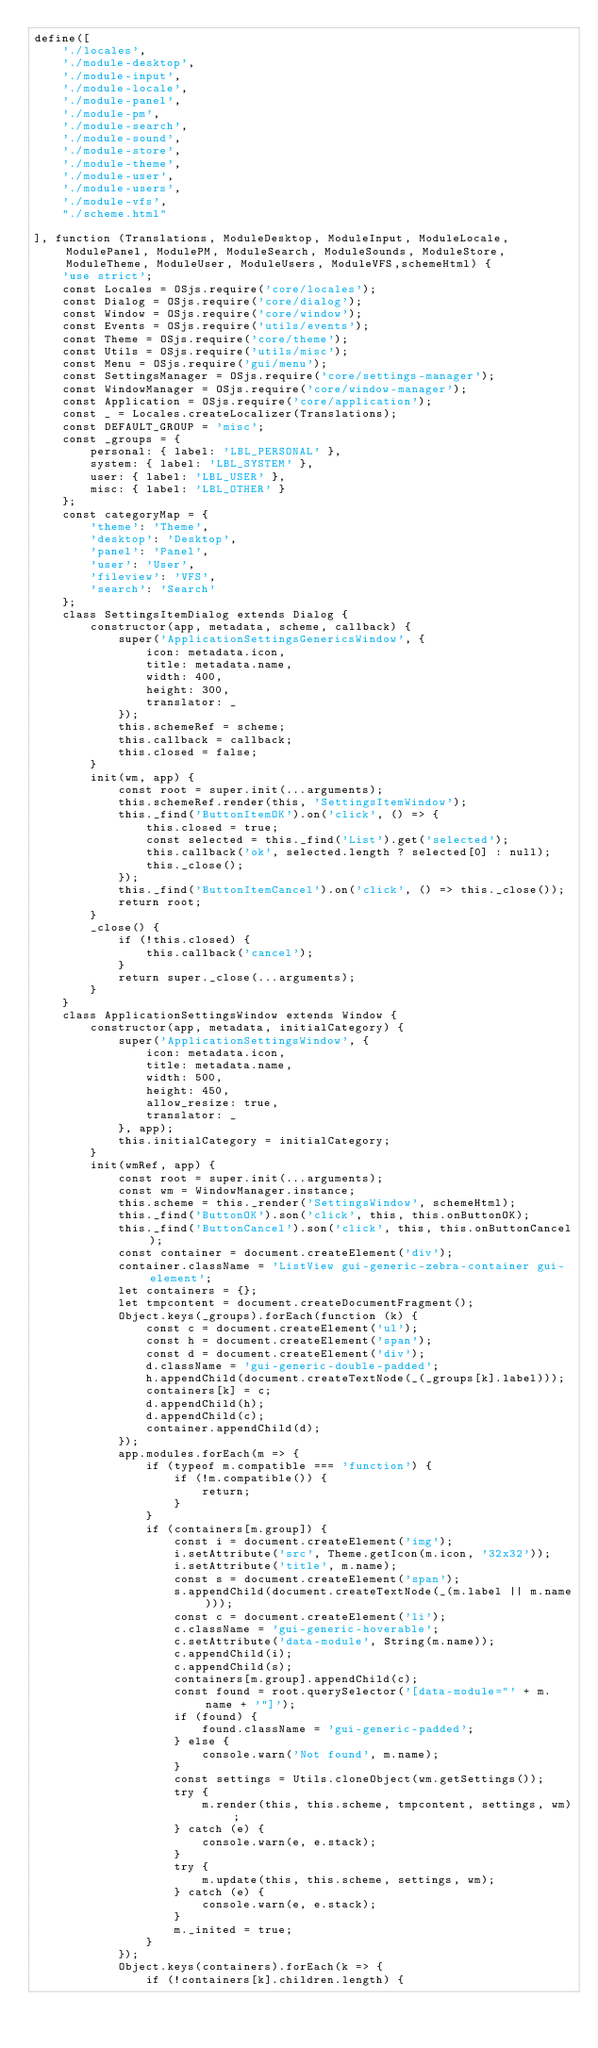Convert code to text. <code><loc_0><loc_0><loc_500><loc_500><_JavaScript_>define([
    './locales',
    './module-desktop',
    './module-input',
    './module-locale',
    './module-panel',
    './module-pm',
    './module-search',
    './module-sound',
    './module-store',
    './module-theme',
    './module-user',
    './module-users',
    './module-vfs',
    "./scheme.html"

], function (Translations, ModuleDesktop, ModuleInput, ModuleLocale, ModulePanel, ModulePM, ModuleSearch, ModuleSounds, ModuleStore, ModuleTheme, ModuleUser, ModuleUsers, ModuleVFS,schemeHtml) {
    'use strict';
    const Locales = OSjs.require('core/locales');
    const Dialog = OSjs.require('core/dialog');
    const Window = OSjs.require('core/window');
    const Events = OSjs.require('utils/events');
    const Theme = OSjs.require('core/theme');
    const Utils = OSjs.require('utils/misc');
    const Menu = OSjs.require('gui/menu');
    const SettingsManager = OSjs.require('core/settings-manager');
    const WindowManager = OSjs.require('core/window-manager');
    const Application = OSjs.require('core/application');
    const _ = Locales.createLocalizer(Translations);
    const DEFAULT_GROUP = 'misc';
    const _groups = {
        personal: { label: 'LBL_PERSONAL' },
        system: { label: 'LBL_SYSTEM' },
        user: { label: 'LBL_USER' },
        misc: { label: 'LBL_OTHER' }
    };
    const categoryMap = {
        'theme': 'Theme',
        'desktop': 'Desktop',
        'panel': 'Panel',
        'user': 'User',
        'fileview': 'VFS',
        'search': 'Search'
    };
    class SettingsItemDialog extends Dialog {
        constructor(app, metadata, scheme, callback) {
            super('ApplicationSettingsGenericsWindow', {
                icon: metadata.icon,
                title: metadata.name,
                width: 400,
                height: 300,
                translator: _
            });
            this.schemeRef = scheme;
            this.callback = callback;
            this.closed = false;
        }
        init(wm, app) {
            const root = super.init(...arguments);
            this.schemeRef.render(this, 'SettingsItemWindow');
            this._find('ButtonItemOK').on('click', () => {
                this.closed = true;
                const selected = this._find('List').get('selected');
                this.callback('ok', selected.length ? selected[0] : null);
                this._close();
            });
            this._find('ButtonItemCancel').on('click', () => this._close());
            return root;
        }
        _close() {
            if (!this.closed) {
                this.callback('cancel');
            }
            return super._close(...arguments);
        }
    }
    class ApplicationSettingsWindow extends Window {
        constructor(app, metadata, initialCategory) {
            super('ApplicationSettingsWindow', {
                icon: metadata.icon,
                title: metadata.name,
                width: 500,
                height: 450,
                allow_resize: true,
                translator: _
            }, app);
            this.initialCategory = initialCategory;
        }
        init(wmRef, app) {
            const root = super.init(...arguments);
            const wm = WindowManager.instance;
            this.scheme = this._render('SettingsWindow', schemeHtml);
            this._find('ButtonOK').son('click', this, this.onButtonOK);
            this._find('ButtonCancel').son('click', this, this.onButtonCancel);
            const container = document.createElement('div');
            container.className = 'ListView gui-generic-zebra-container gui-element';
            let containers = {};
            let tmpcontent = document.createDocumentFragment();
            Object.keys(_groups).forEach(function (k) {
                const c = document.createElement('ul');
                const h = document.createElement('span');
                const d = document.createElement('div');
                d.className = 'gui-generic-double-padded';
                h.appendChild(document.createTextNode(_(_groups[k].label)));
                containers[k] = c;
                d.appendChild(h);
                d.appendChild(c);
                container.appendChild(d);
            });
            app.modules.forEach(m => {
                if (typeof m.compatible === 'function') {
                    if (!m.compatible()) {
                        return;
                    }
                }
                if (containers[m.group]) {
                    const i = document.createElement('img');
                    i.setAttribute('src', Theme.getIcon(m.icon, '32x32'));
                    i.setAttribute('title', m.name);
                    const s = document.createElement('span');
                    s.appendChild(document.createTextNode(_(m.label || m.name)));
                    const c = document.createElement('li');
                    c.className = 'gui-generic-hoverable';
                    c.setAttribute('data-module', String(m.name));
                    c.appendChild(i);
                    c.appendChild(s);
                    containers[m.group].appendChild(c);
                    const found = root.querySelector('[data-module="' + m.name + '"]');
                    if (found) {
                        found.className = 'gui-generic-padded';
                    } else {
                        console.warn('Not found', m.name);
                    }
                    const settings = Utils.cloneObject(wm.getSettings());
                    try {
                        m.render(this, this.scheme, tmpcontent, settings, wm);
                    } catch (e) {
                        console.warn(e, e.stack);
                    }
                    try {
                        m.update(this, this.scheme, settings, wm);
                    } catch (e) {
                        console.warn(e, e.stack);
                    }
                    m._inited = true;
                }
            });
            Object.keys(containers).forEach(k => {
                if (!containers[k].children.length) {</code> 